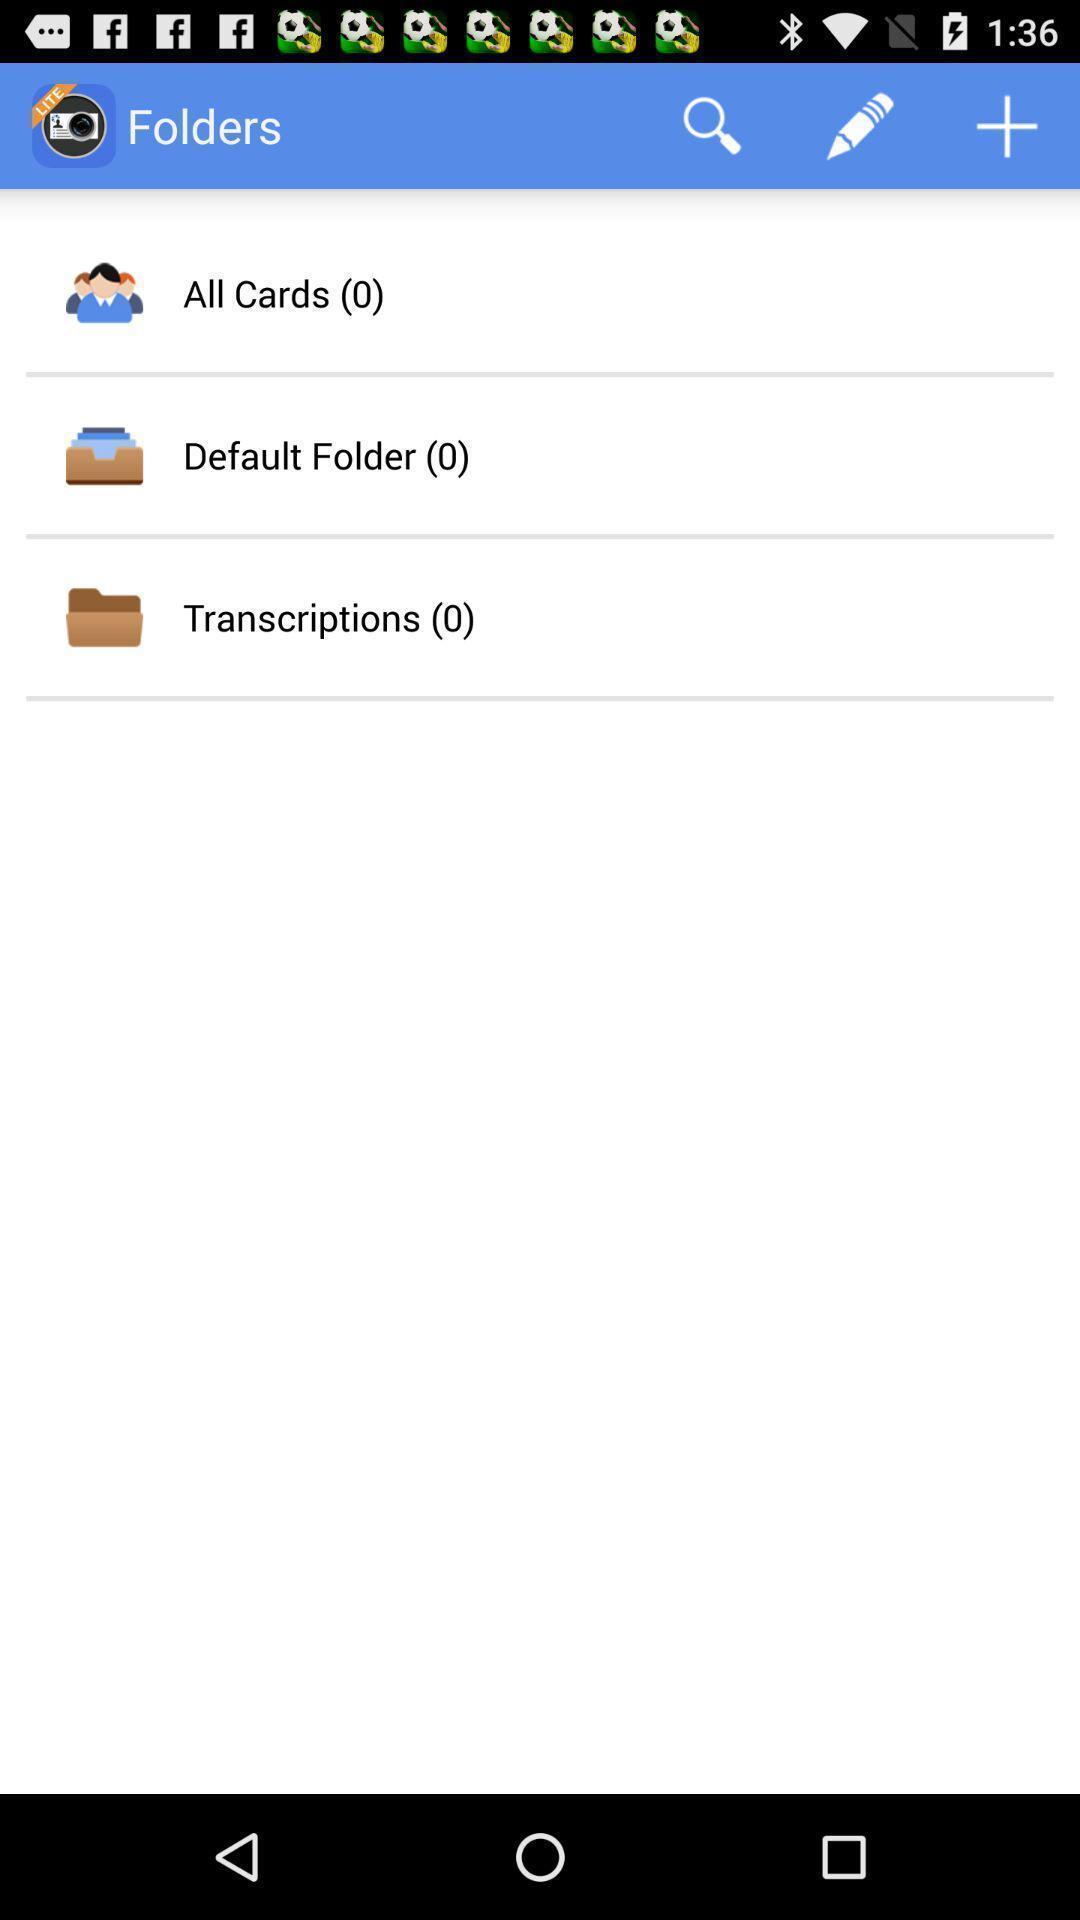What details can you identify in this image? Window displaying a app for business cards. 